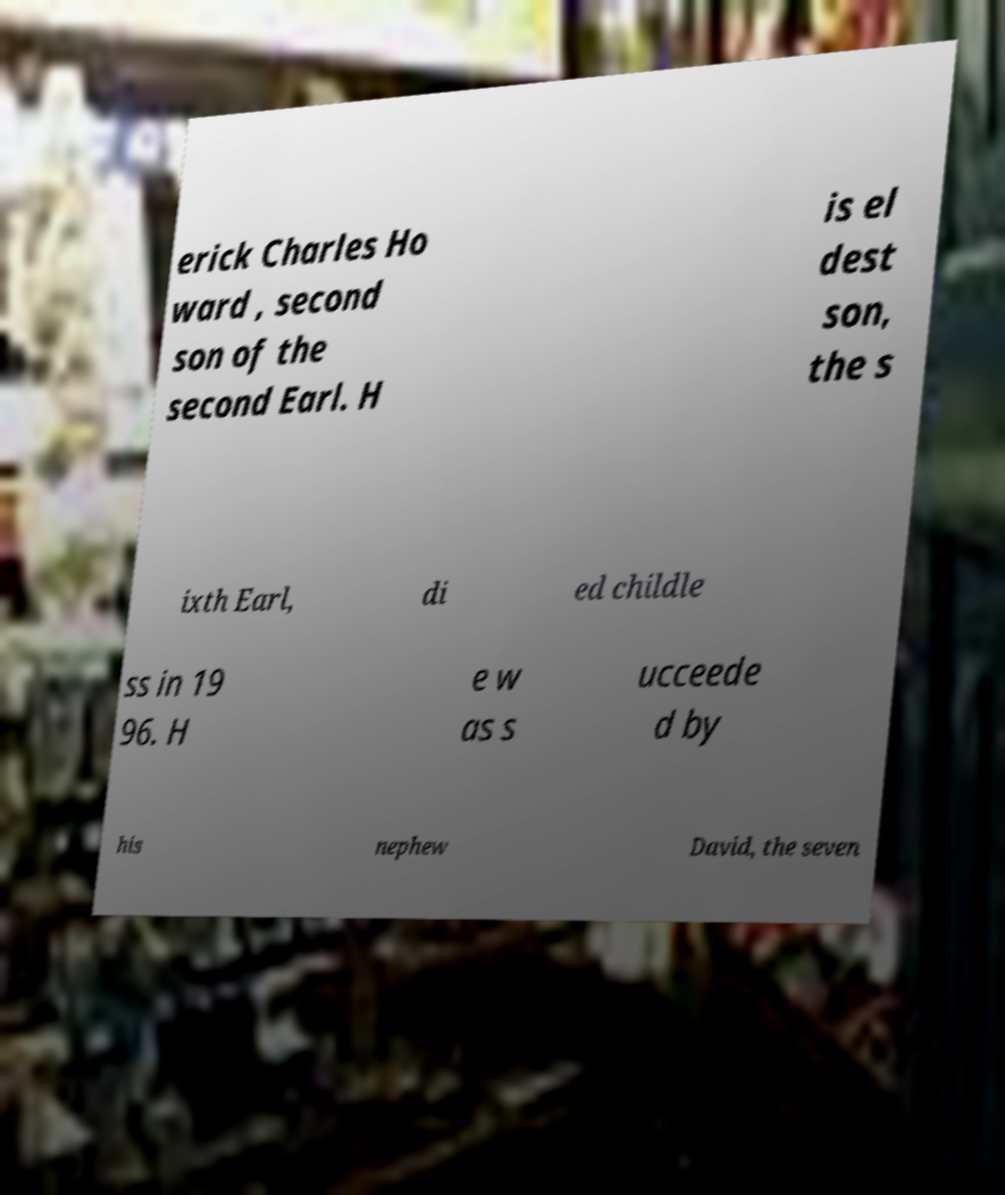Could you extract and type out the text from this image? erick Charles Ho ward , second son of the second Earl. H is el dest son, the s ixth Earl, di ed childle ss in 19 96. H e w as s ucceede d by his nephew David, the seven 